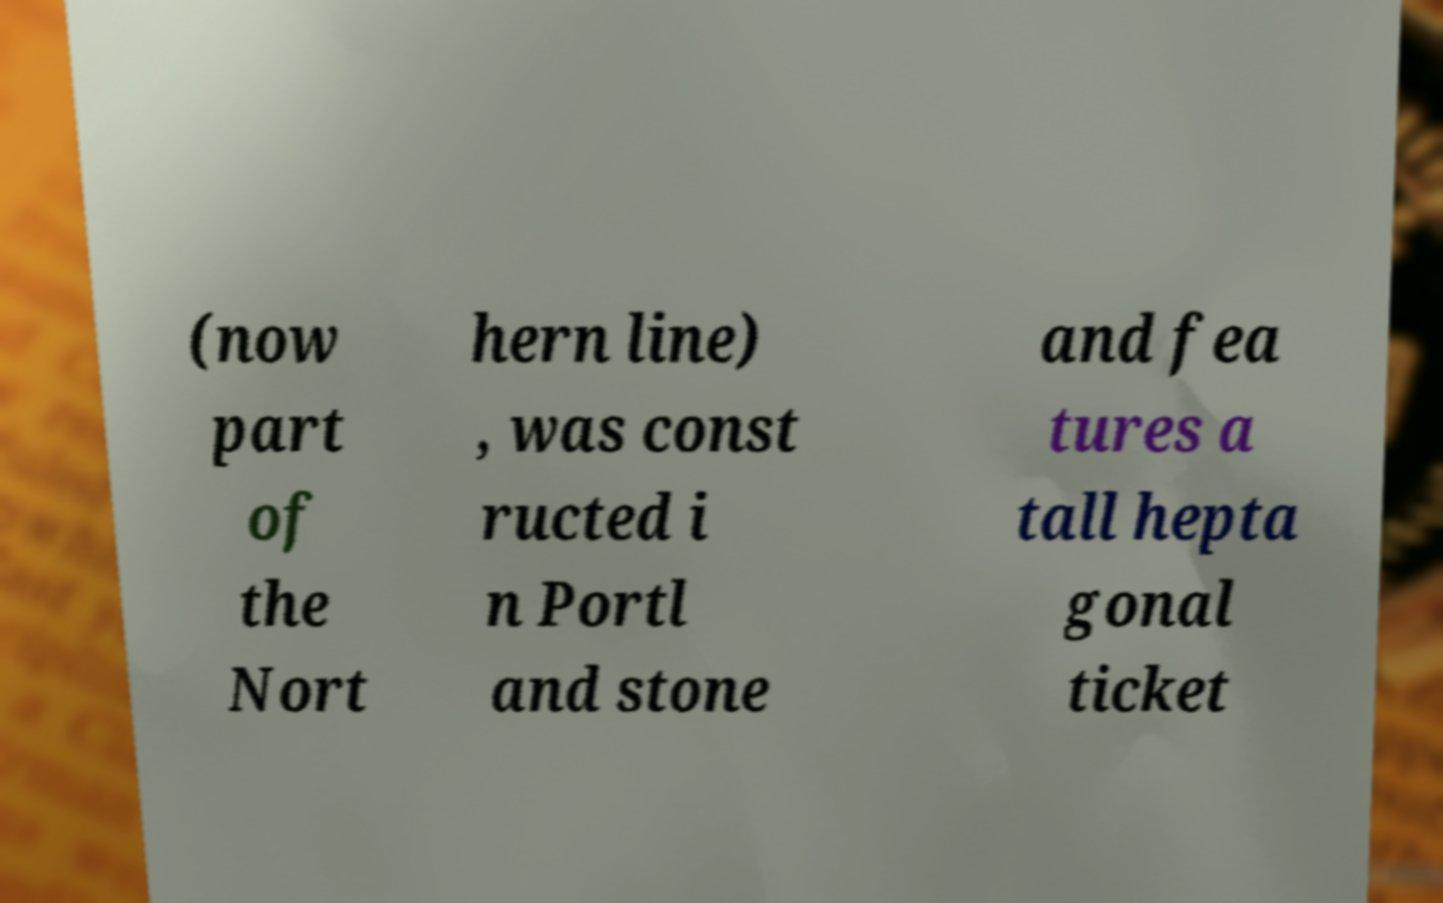Can you read and provide the text displayed in the image?This photo seems to have some interesting text. Can you extract and type it out for me? (now part of the Nort hern line) , was const ructed i n Portl and stone and fea tures a tall hepta gonal ticket 